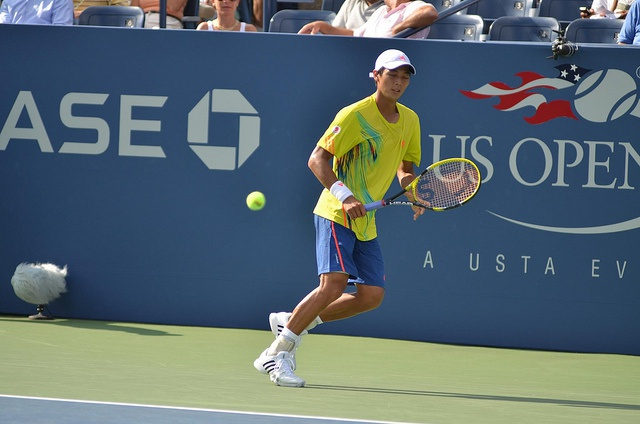Describe the objects in this image and their specific colors. I can see people in gray, olive, blue, and navy tones, people in gray, white, brown, lightpink, and darkgray tones, tennis racket in gray, darkgray, and blue tones, people in gray, darkgray, and lavender tones, and chair in gray, darkblue, navy, and darkgray tones in this image. 